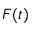Convert formula to latex. <formula><loc_0><loc_0><loc_500><loc_500>F ( t )</formula> 